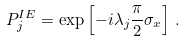<formula> <loc_0><loc_0><loc_500><loc_500>P _ { j } ^ { I E } = \exp \left [ - i \lambda _ { j } \frac { \pi } { 2 } \sigma _ { x } \right ] \, .</formula> 